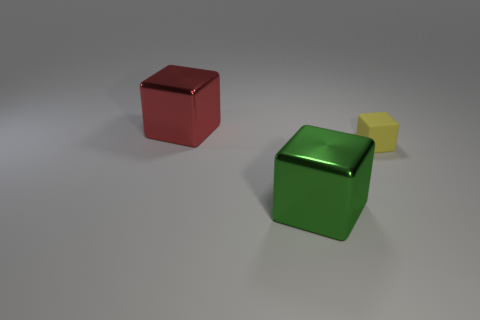What shape is the red shiny object that is the same size as the green cube?
Provide a short and direct response. Cube. Are there any small matte cubes of the same color as the tiny thing?
Provide a succinct answer. No. There is a tiny block; does it have the same color as the big metal object that is in front of the tiny matte block?
Ensure brevity in your answer.  No. There is a metal cube in front of the large red shiny cube that is to the left of the large green metal object; what is its color?
Provide a succinct answer. Green. Are there any rubber things that are in front of the object to the left of the large shiny cube in front of the red metallic block?
Provide a short and direct response. Yes. The large cube that is made of the same material as the red thing is what color?
Ensure brevity in your answer.  Green. What number of small yellow things have the same material as the large green thing?
Ensure brevity in your answer.  0. Does the big red object have the same material as the green thing in front of the yellow matte cube?
Give a very brief answer. Yes. What number of things are objects that are to the right of the green metallic block or green objects?
Your answer should be very brief. 2. There is a shiny block on the left side of the big block that is to the right of the big metallic cube that is behind the big green shiny thing; what size is it?
Offer a terse response. Large. 